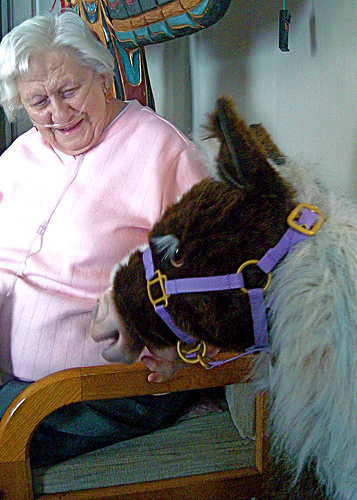<image>
Is there a finger behind the animal? Yes. From this viewpoint, the finger is positioned behind the animal, with the animal partially or fully occluding the finger. Is the halter behind the chair? No. The halter is not behind the chair. From this viewpoint, the halter appears to be positioned elsewhere in the scene. Where is the farm animal in relation to the cushion? Is it next to the cushion? Yes. The farm animal is positioned adjacent to the cushion, located nearby in the same general area. 